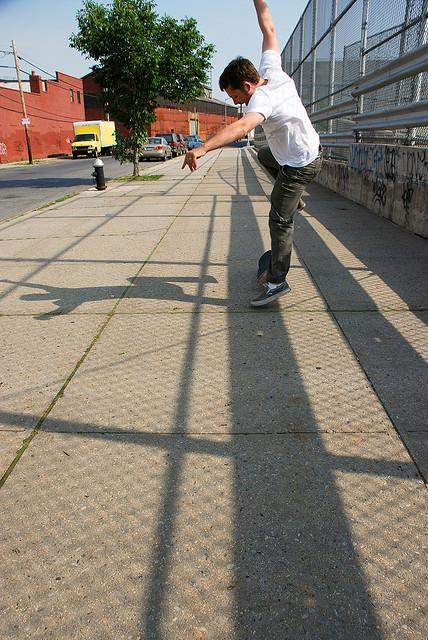The shadow of what is visible? fence 